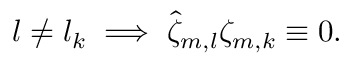<formula> <loc_0><loc_0><loc_500><loc_500>l \neq l _ { k } \implies \hat { \zeta } _ { m , l } \zeta _ { m , k } \equiv 0 .</formula> 